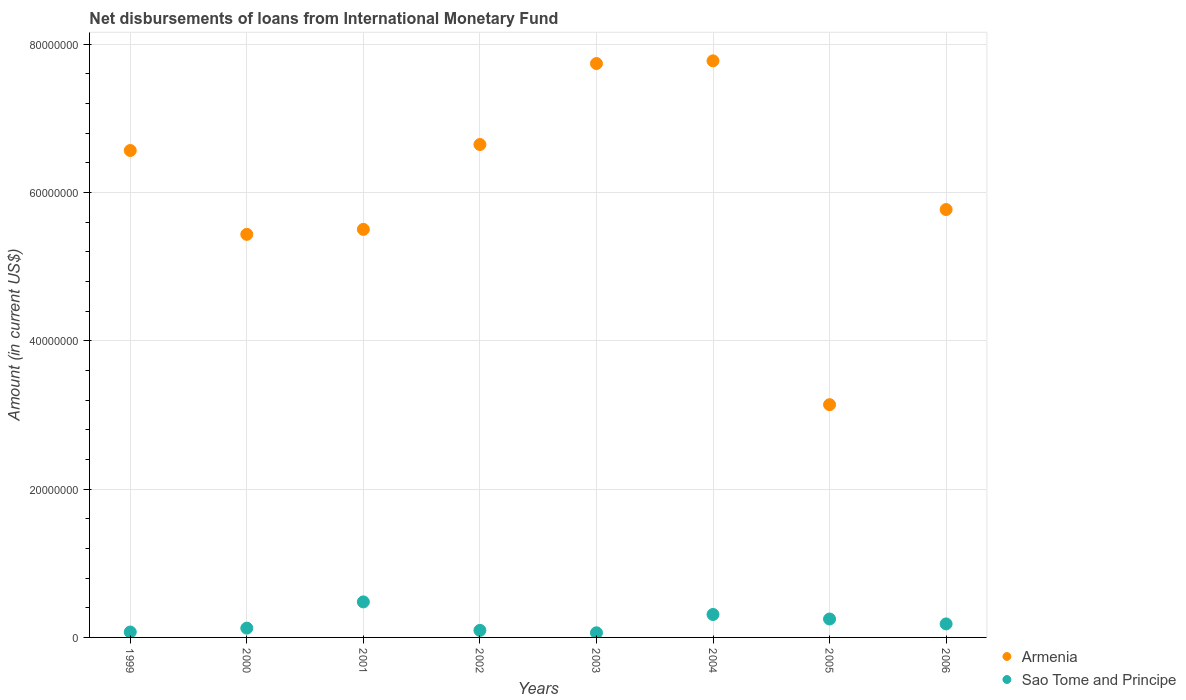What is the amount of loans disbursed in Armenia in 2005?
Your answer should be compact. 3.14e+07. Across all years, what is the maximum amount of loans disbursed in Armenia?
Offer a very short reply. 7.78e+07. Across all years, what is the minimum amount of loans disbursed in Armenia?
Offer a very short reply. 3.14e+07. In which year was the amount of loans disbursed in Sao Tome and Principe maximum?
Your response must be concise. 2001. What is the total amount of loans disbursed in Sao Tome and Principe in the graph?
Ensure brevity in your answer.  1.57e+07. What is the difference between the amount of loans disbursed in Armenia in 2001 and that in 2003?
Make the answer very short. -2.24e+07. What is the difference between the amount of loans disbursed in Sao Tome and Principe in 1999 and the amount of loans disbursed in Armenia in 2001?
Provide a short and direct response. -5.43e+07. What is the average amount of loans disbursed in Armenia per year?
Make the answer very short. 6.07e+07. In the year 2000, what is the difference between the amount of loans disbursed in Armenia and amount of loans disbursed in Sao Tome and Principe?
Offer a terse response. 5.31e+07. In how many years, is the amount of loans disbursed in Armenia greater than 72000000 US$?
Offer a terse response. 2. What is the ratio of the amount of loans disbursed in Armenia in 2001 to that in 2002?
Ensure brevity in your answer.  0.83. What is the difference between the highest and the second highest amount of loans disbursed in Sao Tome and Principe?
Ensure brevity in your answer.  1.70e+06. What is the difference between the highest and the lowest amount of loans disbursed in Sao Tome and Principe?
Ensure brevity in your answer.  4.16e+06. In how many years, is the amount of loans disbursed in Armenia greater than the average amount of loans disbursed in Armenia taken over all years?
Offer a terse response. 4. Is the sum of the amount of loans disbursed in Sao Tome and Principe in 2001 and 2004 greater than the maximum amount of loans disbursed in Armenia across all years?
Keep it short and to the point. No. Does the amount of loans disbursed in Sao Tome and Principe monotonically increase over the years?
Give a very brief answer. No. What is the difference between two consecutive major ticks on the Y-axis?
Offer a terse response. 2.00e+07. Where does the legend appear in the graph?
Ensure brevity in your answer.  Bottom right. What is the title of the graph?
Offer a very short reply. Net disbursements of loans from International Monetary Fund. What is the label or title of the Y-axis?
Provide a short and direct response. Amount (in current US$). What is the Amount (in current US$) of Armenia in 1999?
Ensure brevity in your answer.  6.57e+07. What is the Amount (in current US$) in Sao Tome and Principe in 1999?
Make the answer very short. 7.30e+05. What is the Amount (in current US$) of Armenia in 2000?
Make the answer very short. 5.44e+07. What is the Amount (in current US$) in Sao Tome and Principe in 2000?
Give a very brief answer. 1.25e+06. What is the Amount (in current US$) in Armenia in 2001?
Provide a succinct answer. 5.50e+07. What is the Amount (in current US$) of Sao Tome and Principe in 2001?
Your answer should be very brief. 4.79e+06. What is the Amount (in current US$) in Armenia in 2002?
Ensure brevity in your answer.  6.65e+07. What is the Amount (in current US$) of Sao Tome and Principe in 2002?
Give a very brief answer. 9.49e+05. What is the Amount (in current US$) in Armenia in 2003?
Offer a very short reply. 7.74e+07. What is the Amount (in current US$) of Sao Tome and Principe in 2003?
Provide a short and direct response. 6.26e+05. What is the Amount (in current US$) of Armenia in 2004?
Provide a short and direct response. 7.78e+07. What is the Amount (in current US$) in Sao Tome and Principe in 2004?
Your response must be concise. 3.10e+06. What is the Amount (in current US$) of Armenia in 2005?
Offer a terse response. 3.14e+07. What is the Amount (in current US$) of Sao Tome and Principe in 2005?
Your answer should be very brief. 2.48e+06. What is the Amount (in current US$) in Armenia in 2006?
Your answer should be very brief. 5.77e+07. What is the Amount (in current US$) in Sao Tome and Principe in 2006?
Offer a very short reply. 1.82e+06. Across all years, what is the maximum Amount (in current US$) of Armenia?
Provide a succinct answer. 7.78e+07. Across all years, what is the maximum Amount (in current US$) of Sao Tome and Principe?
Offer a very short reply. 4.79e+06. Across all years, what is the minimum Amount (in current US$) in Armenia?
Provide a succinct answer. 3.14e+07. Across all years, what is the minimum Amount (in current US$) in Sao Tome and Principe?
Your answer should be very brief. 6.26e+05. What is the total Amount (in current US$) in Armenia in the graph?
Make the answer very short. 4.86e+08. What is the total Amount (in current US$) in Sao Tome and Principe in the graph?
Your answer should be compact. 1.57e+07. What is the difference between the Amount (in current US$) in Armenia in 1999 and that in 2000?
Keep it short and to the point. 1.13e+07. What is the difference between the Amount (in current US$) in Sao Tome and Principe in 1999 and that in 2000?
Provide a succinct answer. -5.21e+05. What is the difference between the Amount (in current US$) in Armenia in 1999 and that in 2001?
Offer a very short reply. 1.06e+07. What is the difference between the Amount (in current US$) in Sao Tome and Principe in 1999 and that in 2001?
Ensure brevity in your answer.  -4.06e+06. What is the difference between the Amount (in current US$) in Armenia in 1999 and that in 2002?
Provide a succinct answer. -8.07e+05. What is the difference between the Amount (in current US$) in Sao Tome and Principe in 1999 and that in 2002?
Make the answer very short. -2.19e+05. What is the difference between the Amount (in current US$) in Armenia in 1999 and that in 2003?
Your answer should be compact. -1.17e+07. What is the difference between the Amount (in current US$) in Sao Tome and Principe in 1999 and that in 2003?
Offer a terse response. 1.04e+05. What is the difference between the Amount (in current US$) of Armenia in 1999 and that in 2004?
Provide a short and direct response. -1.21e+07. What is the difference between the Amount (in current US$) in Sao Tome and Principe in 1999 and that in 2004?
Your answer should be compact. -2.36e+06. What is the difference between the Amount (in current US$) in Armenia in 1999 and that in 2005?
Provide a short and direct response. 3.43e+07. What is the difference between the Amount (in current US$) in Sao Tome and Principe in 1999 and that in 2005?
Provide a short and direct response. -1.76e+06. What is the difference between the Amount (in current US$) in Armenia in 1999 and that in 2006?
Your response must be concise. 7.96e+06. What is the difference between the Amount (in current US$) in Sao Tome and Principe in 1999 and that in 2006?
Provide a succinct answer. -1.09e+06. What is the difference between the Amount (in current US$) in Armenia in 2000 and that in 2001?
Your answer should be very brief. -6.72e+05. What is the difference between the Amount (in current US$) of Sao Tome and Principe in 2000 and that in 2001?
Your answer should be compact. -3.54e+06. What is the difference between the Amount (in current US$) in Armenia in 2000 and that in 2002?
Your answer should be compact. -1.21e+07. What is the difference between the Amount (in current US$) in Sao Tome and Principe in 2000 and that in 2002?
Provide a short and direct response. 3.02e+05. What is the difference between the Amount (in current US$) of Armenia in 2000 and that in 2003?
Ensure brevity in your answer.  -2.30e+07. What is the difference between the Amount (in current US$) of Sao Tome and Principe in 2000 and that in 2003?
Your answer should be compact. 6.25e+05. What is the difference between the Amount (in current US$) of Armenia in 2000 and that in 2004?
Your answer should be very brief. -2.34e+07. What is the difference between the Amount (in current US$) of Sao Tome and Principe in 2000 and that in 2004?
Provide a succinct answer. -1.84e+06. What is the difference between the Amount (in current US$) in Armenia in 2000 and that in 2005?
Provide a succinct answer. 2.30e+07. What is the difference between the Amount (in current US$) in Sao Tome and Principe in 2000 and that in 2005?
Offer a terse response. -1.23e+06. What is the difference between the Amount (in current US$) in Armenia in 2000 and that in 2006?
Your response must be concise. -3.34e+06. What is the difference between the Amount (in current US$) of Sao Tome and Principe in 2000 and that in 2006?
Offer a terse response. -5.72e+05. What is the difference between the Amount (in current US$) in Armenia in 2001 and that in 2002?
Offer a terse response. -1.14e+07. What is the difference between the Amount (in current US$) of Sao Tome and Principe in 2001 and that in 2002?
Make the answer very short. 3.84e+06. What is the difference between the Amount (in current US$) of Armenia in 2001 and that in 2003?
Provide a short and direct response. -2.24e+07. What is the difference between the Amount (in current US$) in Sao Tome and Principe in 2001 and that in 2003?
Offer a very short reply. 4.16e+06. What is the difference between the Amount (in current US$) in Armenia in 2001 and that in 2004?
Your response must be concise. -2.27e+07. What is the difference between the Amount (in current US$) in Sao Tome and Principe in 2001 and that in 2004?
Make the answer very short. 1.70e+06. What is the difference between the Amount (in current US$) of Armenia in 2001 and that in 2005?
Give a very brief answer. 2.36e+07. What is the difference between the Amount (in current US$) in Sao Tome and Principe in 2001 and that in 2005?
Provide a short and direct response. 2.30e+06. What is the difference between the Amount (in current US$) of Armenia in 2001 and that in 2006?
Give a very brief answer. -2.67e+06. What is the difference between the Amount (in current US$) in Sao Tome and Principe in 2001 and that in 2006?
Ensure brevity in your answer.  2.97e+06. What is the difference between the Amount (in current US$) in Armenia in 2002 and that in 2003?
Your answer should be compact. -1.09e+07. What is the difference between the Amount (in current US$) of Sao Tome and Principe in 2002 and that in 2003?
Provide a short and direct response. 3.23e+05. What is the difference between the Amount (in current US$) in Armenia in 2002 and that in 2004?
Ensure brevity in your answer.  -1.13e+07. What is the difference between the Amount (in current US$) of Sao Tome and Principe in 2002 and that in 2004?
Provide a short and direct response. -2.15e+06. What is the difference between the Amount (in current US$) of Armenia in 2002 and that in 2005?
Ensure brevity in your answer.  3.51e+07. What is the difference between the Amount (in current US$) in Sao Tome and Principe in 2002 and that in 2005?
Your answer should be very brief. -1.54e+06. What is the difference between the Amount (in current US$) of Armenia in 2002 and that in 2006?
Provide a succinct answer. 8.77e+06. What is the difference between the Amount (in current US$) in Sao Tome and Principe in 2002 and that in 2006?
Your answer should be very brief. -8.74e+05. What is the difference between the Amount (in current US$) of Armenia in 2003 and that in 2004?
Your answer should be very brief. -3.65e+05. What is the difference between the Amount (in current US$) in Sao Tome and Principe in 2003 and that in 2004?
Offer a terse response. -2.47e+06. What is the difference between the Amount (in current US$) of Armenia in 2003 and that in 2005?
Make the answer very short. 4.60e+07. What is the difference between the Amount (in current US$) in Sao Tome and Principe in 2003 and that in 2005?
Offer a terse response. -1.86e+06. What is the difference between the Amount (in current US$) in Armenia in 2003 and that in 2006?
Ensure brevity in your answer.  1.97e+07. What is the difference between the Amount (in current US$) in Sao Tome and Principe in 2003 and that in 2006?
Provide a short and direct response. -1.20e+06. What is the difference between the Amount (in current US$) in Armenia in 2004 and that in 2005?
Keep it short and to the point. 4.64e+07. What is the difference between the Amount (in current US$) of Sao Tome and Principe in 2004 and that in 2005?
Your answer should be very brief. 6.10e+05. What is the difference between the Amount (in current US$) in Armenia in 2004 and that in 2006?
Your response must be concise. 2.01e+07. What is the difference between the Amount (in current US$) in Sao Tome and Principe in 2004 and that in 2006?
Provide a succinct answer. 1.27e+06. What is the difference between the Amount (in current US$) in Armenia in 2005 and that in 2006?
Offer a terse response. -2.63e+07. What is the difference between the Amount (in current US$) of Sao Tome and Principe in 2005 and that in 2006?
Make the answer very short. 6.62e+05. What is the difference between the Amount (in current US$) in Armenia in 1999 and the Amount (in current US$) in Sao Tome and Principe in 2000?
Make the answer very short. 6.44e+07. What is the difference between the Amount (in current US$) of Armenia in 1999 and the Amount (in current US$) of Sao Tome and Principe in 2001?
Your answer should be very brief. 6.09e+07. What is the difference between the Amount (in current US$) in Armenia in 1999 and the Amount (in current US$) in Sao Tome and Principe in 2002?
Your answer should be very brief. 6.47e+07. What is the difference between the Amount (in current US$) in Armenia in 1999 and the Amount (in current US$) in Sao Tome and Principe in 2003?
Make the answer very short. 6.50e+07. What is the difference between the Amount (in current US$) of Armenia in 1999 and the Amount (in current US$) of Sao Tome and Principe in 2004?
Offer a terse response. 6.26e+07. What is the difference between the Amount (in current US$) of Armenia in 1999 and the Amount (in current US$) of Sao Tome and Principe in 2005?
Make the answer very short. 6.32e+07. What is the difference between the Amount (in current US$) in Armenia in 1999 and the Amount (in current US$) in Sao Tome and Principe in 2006?
Keep it short and to the point. 6.38e+07. What is the difference between the Amount (in current US$) in Armenia in 2000 and the Amount (in current US$) in Sao Tome and Principe in 2001?
Your answer should be very brief. 4.96e+07. What is the difference between the Amount (in current US$) of Armenia in 2000 and the Amount (in current US$) of Sao Tome and Principe in 2002?
Offer a very short reply. 5.34e+07. What is the difference between the Amount (in current US$) of Armenia in 2000 and the Amount (in current US$) of Sao Tome and Principe in 2003?
Your answer should be very brief. 5.37e+07. What is the difference between the Amount (in current US$) of Armenia in 2000 and the Amount (in current US$) of Sao Tome and Principe in 2004?
Keep it short and to the point. 5.13e+07. What is the difference between the Amount (in current US$) of Armenia in 2000 and the Amount (in current US$) of Sao Tome and Principe in 2005?
Ensure brevity in your answer.  5.19e+07. What is the difference between the Amount (in current US$) of Armenia in 2000 and the Amount (in current US$) of Sao Tome and Principe in 2006?
Make the answer very short. 5.25e+07. What is the difference between the Amount (in current US$) in Armenia in 2001 and the Amount (in current US$) in Sao Tome and Principe in 2002?
Provide a succinct answer. 5.41e+07. What is the difference between the Amount (in current US$) of Armenia in 2001 and the Amount (in current US$) of Sao Tome and Principe in 2003?
Your answer should be compact. 5.44e+07. What is the difference between the Amount (in current US$) in Armenia in 2001 and the Amount (in current US$) in Sao Tome and Principe in 2004?
Offer a terse response. 5.19e+07. What is the difference between the Amount (in current US$) of Armenia in 2001 and the Amount (in current US$) of Sao Tome and Principe in 2005?
Ensure brevity in your answer.  5.25e+07. What is the difference between the Amount (in current US$) of Armenia in 2001 and the Amount (in current US$) of Sao Tome and Principe in 2006?
Keep it short and to the point. 5.32e+07. What is the difference between the Amount (in current US$) in Armenia in 2002 and the Amount (in current US$) in Sao Tome and Principe in 2003?
Ensure brevity in your answer.  6.58e+07. What is the difference between the Amount (in current US$) of Armenia in 2002 and the Amount (in current US$) of Sao Tome and Principe in 2004?
Ensure brevity in your answer.  6.34e+07. What is the difference between the Amount (in current US$) in Armenia in 2002 and the Amount (in current US$) in Sao Tome and Principe in 2005?
Provide a short and direct response. 6.40e+07. What is the difference between the Amount (in current US$) of Armenia in 2002 and the Amount (in current US$) of Sao Tome and Principe in 2006?
Keep it short and to the point. 6.46e+07. What is the difference between the Amount (in current US$) in Armenia in 2003 and the Amount (in current US$) in Sao Tome and Principe in 2004?
Provide a succinct answer. 7.43e+07. What is the difference between the Amount (in current US$) in Armenia in 2003 and the Amount (in current US$) in Sao Tome and Principe in 2005?
Make the answer very short. 7.49e+07. What is the difference between the Amount (in current US$) of Armenia in 2003 and the Amount (in current US$) of Sao Tome and Principe in 2006?
Your answer should be compact. 7.56e+07. What is the difference between the Amount (in current US$) of Armenia in 2004 and the Amount (in current US$) of Sao Tome and Principe in 2005?
Provide a succinct answer. 7.53e+07. What is the difference between the Amount (in current US$) of Armenia in 2004 and the Amount (in current US$) of Sao Tome and Principe in 2006?
Give a very brief answer. 7.59e+07. What is the difference between the Amount (in current US$) of Armenia in 2005 and the Amount (in current US$) of Sao Tome and Principe in 2006?
Provide a short and direct response. 2.96e+07. What is the average Amount (in current US$) of Armenia per year?
Ensure brevity in your answer.  6.07e+07. What is the average Amount (in current US$) of Sao Tome and Principe per year?
Your response must be concise. 1.97e+06. In the year 1999, what is the difference between the Amount (in current US$) of Armenia and Amount (in current US$) of Sao Tome and Principe?
Your answer should be very brief. 6.49e+07. In the year 2000, what is the difference between the Amount (in current US$) of Armenia and Amount (in current US$) of Sao Tome and Principe?
Your response must be concise. 5.31e+07. In the year 2001, what is the difference between the Amount (in current US$) of Armenia and Amount (in current US$) of Sao Tome and Principe?
Offer a very short reply. 5.02e+07. In the year 2002, what is the difference between the Amount (in current US$) of Armenia and Amount (in current US$) of Sao Tome and Principe?
Your answer should be very brief. 6.55e+07. In the year 2003, what is the difference between the Amount (in current US$) of Armenia and Amount (in current US$) of Sao Tome and Principe?
Your answer should be compact. 7.68e+07. In the year 2004, what is the difference between the Amount (in current US$) in Armenia and Amount (in current US$) in Sao Tome and Principe?
Ensure brevity in your answer.  7.47e+07. In the year 2005, what is the difference between the Amount (in current US$) of Armenia and Amount (in current US$) of Sao Tome and Principe?
Offer a very short reply. 2.89e+07. In the year 2006, what is the difference between the Amount (in current US$) of Armenia and Amount (in current US$) of Sao Tome and Principe?
Give a very brief answer. 5.59e+07. What is the ratio of the Amount (in current US$) of Armenia in 1999 to that in 2000?
Give a very brief answer. 1.21. What is the ratio of the Amount (in current US$) in Sao Tome and Principe in 1999 to that in 2000?
Offer a very short reply. 0.58. What is the ratio of the Amount (in current US$) of Armenia in 1999 to that in 2001?
Make the answer very short. 1.19. What is the ratio of the Amount (in current US$) in Sao Tome and Principe in 1999 to that in 2001?
Offer a very short reply. 0.15. What is the ratio of the Amount (in current US$) in Armenia in 1999 to that in 2002?
Your answer should be compact. 0.99. What is the ratio of the Amount (in current US$) in Sao Tome and Principe in 1999 to that in 2002?
Your response must be concise. 0.77. What is the ratio of the Amount (in current US$) in Armenia in 1999 to that in 2003?
Give a very brief answer. 0.85. What is the ratio of the Amount (in current US$) in Sao Tome and Principe in 1999 to that in 2003?
Provide a short and direct response. 1.17. What is the ratio of the Amount (in current US$) in Armenia in 1999 to that in 2004?
Provide a succinct answer. 0.84. What is the ratio of the Amount (in current US$) of Sao Tome and Principe in 1999 to that in 2004?
Offer a very short reply. 0.24. What is the ratio of the Amount (in current US$) of Armenia in 1999 to that in 2005?
Your answer should be very brief. 2.09. What is the ratio of the Amount (in current US$) of Sao Tome and Principe in 1999 to that in 2005?
Provide a succinct answer. 0.29. What is the ratio of the Amount (in current US$) of Armenia in 1999 to that in 2006?
Keep it short and to the point. 1.14. What is the ratio of the Amount (in current US$) of Sao Tome and Principe in 1999 to that in 2006?
Make the answer very short. 0.4. What is the ratio of the Amount (in current US$) in Armenia in 2000 to that in 2001?
Provide a succinct answer. 0.99. What is the ratio of the Amount (in current US$) of Sao Tome and Principe in 2000 to that in 2001?
Your answer should be compact. 0.26. What is the ratio of the Amount (in current US$) of Armenia in 2000 to that in 2002?
Your answer should be very brief. 0.82. What is the ratio of the Amount (in current US$) of Sao Tome and Principe in 2000 to that in 2002?
Give a very brief answer. 1.32. What is the ratio of the Amount (in current US$) in Armenia in 2000 to that in 2003?
Make the answer very short. 0.7. What is the ratio of the Amount (in current US$) in Sao Tome and Principe in 2000 to that in 2003?
Keep it short and to the point. 2. What is the ratio of the Amount (in current US$) of Armenia in 2000 to that in 2004?
Your response must be concise. 0.7. What is the ratio of the Amount (in current US$) of Sao Tome and Principe in 2000 to that in 2004?
Your answer should be compact. 0.4. What is the ratio of the Amount (in current US$) of Armenia in 2000 to that in 2005?
Keep it short and to the point. 1.73. What is the ratio of the Amount (in current US$) in Sao Tome and Principe in 2000 to that in 2005?
Keep it short and to the point. 0.5. What is the ratio of the Amount (in current US$) of Armenia in 2000 to that in 2006?
Ensure brevity in your answer.  0.94. What is the ratio of the Amount (in current US$) of Sao Tome and Principe in 2000 to that in 2006?
Ensure brevity in your answer.  0.69. What is the ratio of the Amount (in current US$) in Armenia in 2001 to that in 2002?
Offer a terse response. 0.83. What is the ratio of the Amount (in current US$) of Sao Tome and Principe in 2001 to that in 2002?
Your response must be concise. 5.05. What is the ratio of the Amount (in current US$) of Armenia in 2001 to that in 2003?
Provide a short and direct response. 0.71. What is the ratio of the Amount (in current US$) in Sao Tome and Principe in 2001 to that in 2003?
Offer a very short reply. 7.65. What is the ratio of the Amount (in current US$) of Armenia in 2001 to that in 2004?
Your answer should be very brief. 0.71. What is the ratio of the Amount (in current US$) of Sao Tome and Principe in 2001 to that in 2004?
Offer a very short reply. 1.55. What is the ratio of the Amount (in current US$) of Armenia in 2001 to that in 2005?
Provide a short and direct response. 1.75. What is the ratio of the Amount (in current US$) of Sao Tome and Principe in 2001 to that in 2005?
Your answer should be very brief. 1.93. What is the ratio of the Amount (in current US$) of Armenia in 2001 to that in 2006?
Ensure brevity in your answer.  0.95. What is the ratio of the Amount (in current US$) of Sao Tome and Principe in 2001 to that in 2006?
Keep it short and to the point. 2.63. What is the ratio of the Amount (in current US$) of Armenia in 2002 to that in 2003?
Your answer should be compact. 0.86. What is the ratio of the Amount (in current US$) in Sao Tome and Principe in 2002 to that in 2003?
Offer a terse response. 1.52. What is the ratio of the Amount (in current US$) of Armenia in 2002 to that in 2004?
Offer a very short reply. 0.85. What is the ratio of the Amount (in current US$) in Sao Tome and Principe in 2002 to that in 2004?
Your answer should be compact. 0.31. What is the ratio of the Amount (in current US$) in Armenia in 2002 to that in 2005?
Ensure brevity in your answer.  2.12. What is the ratio of the Amount (in current US$) in Sao Tome and Principe in 2002 to that in 2005?
Give a very brief answer. 0.38. What is the ratio of the Amount (in current US$) of Armenia in 2002 to that in 2006?
Make the answer very short. 1.15. What is the ratio of the Amount (in current US$) of Sao Tome and Principe in 2002 to that in 2006?
Offer a very short reply. 0.52. What is the ratio of the Amount (in current US$) in Armenia in 2003 to that in 2004?
Ensure brevity in your answer.  1. What is the ratio of the Amount (in current US$) in Sao Tome and Principe in 2003 to that in 2004?
Your answer should be very brief. 0.2. What is the ratio of the Amount (in current US$) in Armenia in 2003 to that in 2005?
Your response must be concise. 2.47. What is the ratio of the Amount (in current US$) of Sao Tome and Principe in 2003 to that in 2005?
Offer a terse response. 0.25. What is the ratio of the Amount (in current US$) of Armenia in 2003 to that in 2006?
Provide a succinct answer. 1.34. What is the ratio of the Amount (in current US$) in Sao Tome and Principe in 2003 to that in 2006?
Your answer should be very brief. 0.34. What is the ratio of the Amount (in current US$) of Armenia in 2004 to that in 2005?
Offer a terse response. 2.48. What is the ratio of the Amount (in current US$) of Sao Tome and Principe in 2004 to that in 2005?
Give a very brief answer. 1.25. What is the ratio of the Amount (in current US$) of Armenia in 2004 to that in 2006?
Offer a very short reply. 1.35. What is the ratio of the Amount (in current US$) in Sao Tome and Principe in 2004 to that in 2006?
Your response must be concise. 1.7. What is the ratio of the Amount (in current US$) of Armenia in 2005 to that in 2006?
Provide a short and direct response. 0.54. What is the ratio of the Amount (in current US$) in Sao Tome and Principe in 2005 to that in 2006?
Keep it short and to the point. 1.36. What is the difference between the highest and the second highest Amount (in current US$) in Armenia?
Make the answer very short. 3.65e+05. What is the difference between the highest and the second highest Amount (in current US$) in Sao Tome and Principe?
Your answer should be compact. 1.70e+06. What is the difference between the highest and the lowest Amount (in current US$) in Armenia?
Give a very brief answer. 4.64e+07. What is the difference between the highest and the lowest Amount (in current US$) of Sao Tome and Principe?
Provide a short and direct response. 4.16e+06. 